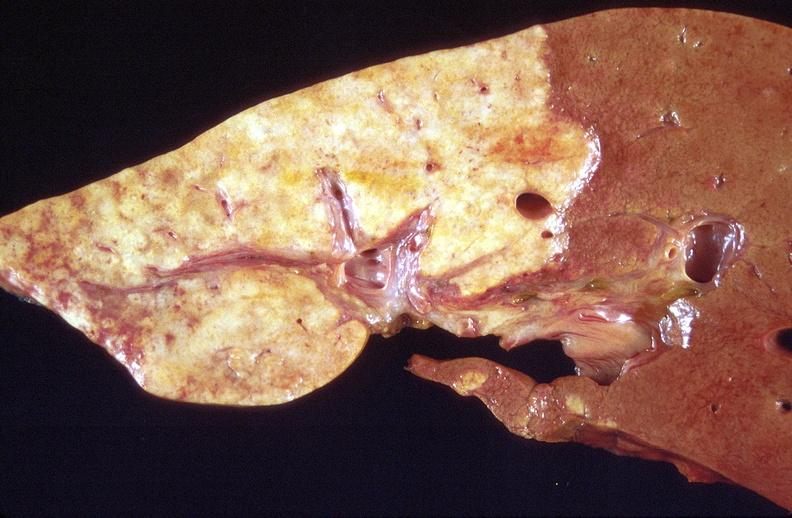s quite good liver present?
Answer the question using a single word or phrase. No 